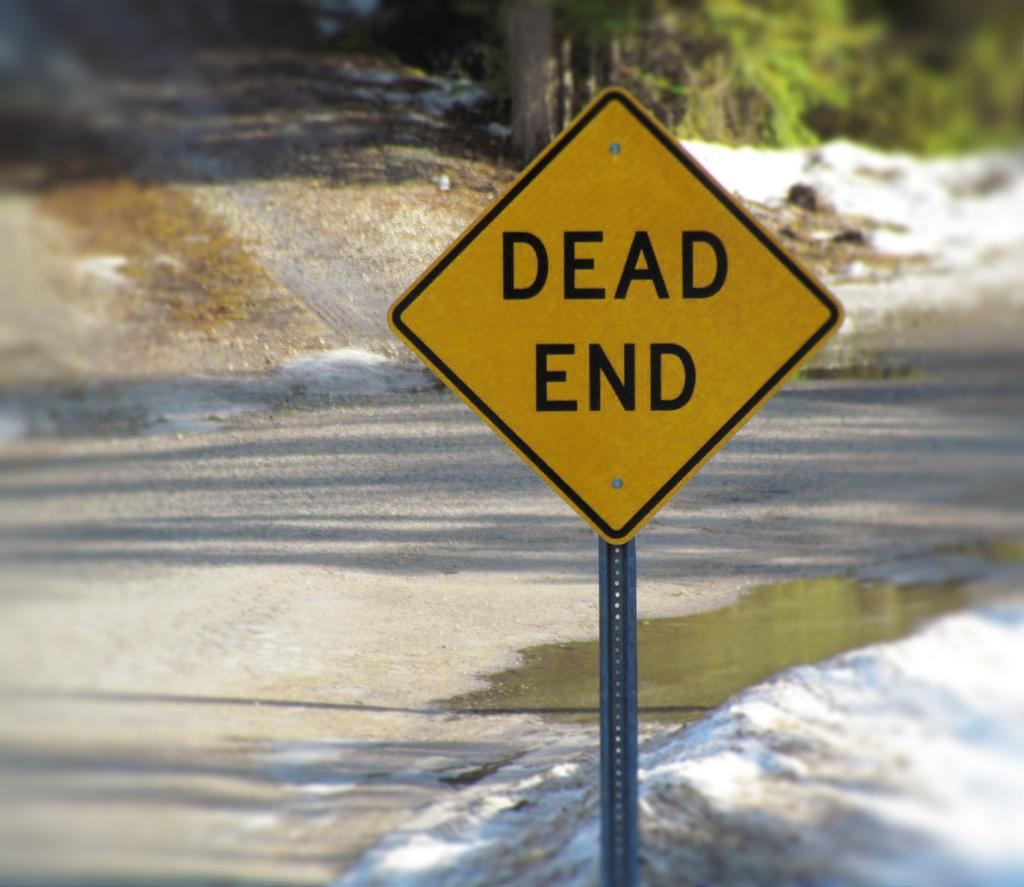<image>
Present a compact description of the photo's key features. A dead end sign is in a pile of slushy snow on the side of the road. 